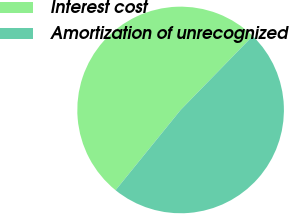<chart> <loc_0><loc_0><loc_500><loc_500><pie_chart><fcel>Interest cost<fcel>Amortization of unrecognized<nl><fcel>51.46%<fcel>48.54%<nl></chart> 